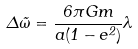Convert formula to latex. <formula><loc_0><loc_0><loc_500><loc_500>\Delta \tilde { \omega } = \frac { 6 \pi G m } { a ( 1 - e ^ { 2 } ) } \lambda</formula> 